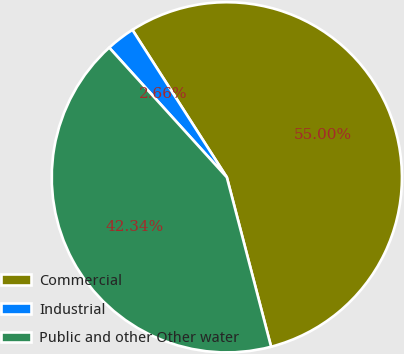<chart> <loc_0><loc_0><loc_500><loc_500><pie_chart><fcel>Commercial<fcel>Industrial<fcel>Public and other Other water<nl><fcel>55.0%<fcel>2.66%<fcel>42.34%<nl></chart> 